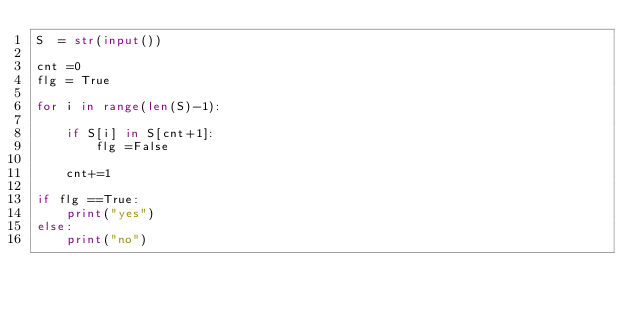Convert code to text. <code><loc_0><loc_0><loc_500><loc_500><_Python_>S  = str(input())

cnt =0
flg = True

for i in range(len(S)-1):
    
    if S[i] in S[cnt+1]:
        flg =False
    
    cnt+=1
    
if flg ==True:
    print("yes")
else:
    print("no")</code> 